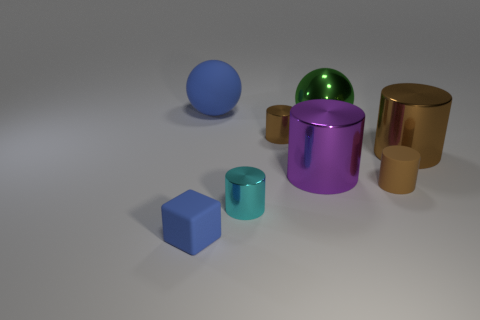The tiny cube is what color?
Offer a very short reply. Blue. Do the big matte object and the small cube have the same color?
Give a very brief answer. Yes. There is a sphere right of the big rubber sphere; what number of small brown rubber cylinders are on the right side of it?
Your response must be concise. 1. How big is the rubber object that is both in front of the matte sphere and behind the blue block?
Provide a short and direct response. Small. What is the material of the big cylinder left of the shiny ball?
Keep it short and to the point. Metal. Is there a small matte object of the same shape as the big brown object?
Your response must be concise. Yes. What number of rubber things have the same shape as the big purple metallic object?
Offer a very short reply. 1. Does the rubber thing that is on the right side of the green ball have the same size as the brown cylinder that is behind the big brown cylinder?
Keep it short and to the point. Yes. The blue matte object that is behind the tiny shiny thing in front of the tiny brown metallic cylinder is what shape?
Make the answer very short. Sphere. Are there an equal number of matte cylinders behind the large brown shiny cylinder and large cyan objects?
Keep it short and to the point. Yes. 